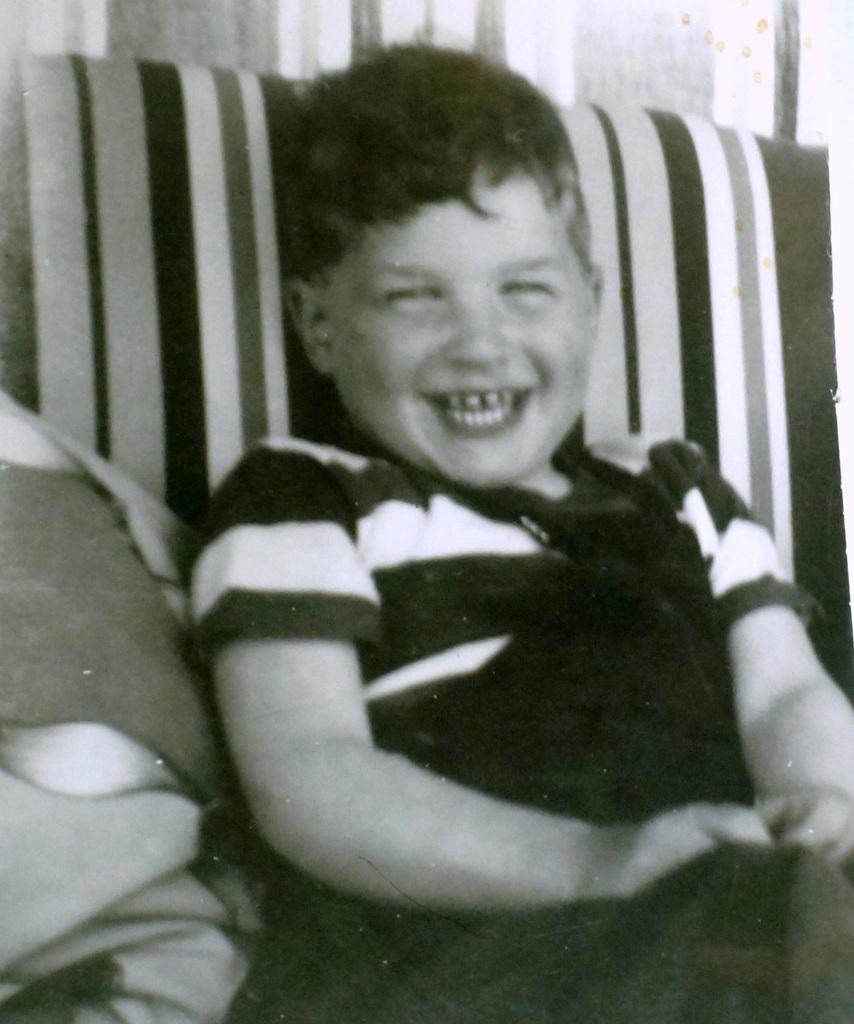Who is the main subject in the image? There is a boy in the image. What is the boy doing in the image? The boy is sitting in the image. What is the boy's facial expression in the image? The boy is smiling in the image. What can be seen on the left side of the image? There are clothes on the left side of the image. What type of pest can be seen crawling on the boy's shoulder in the image? There is no pest visible on the boy's shoulder in the image. What thrilling activity is the boy participating in the image? The image does not depict any thrilling activities; the boy is simply sitting and smiling. 